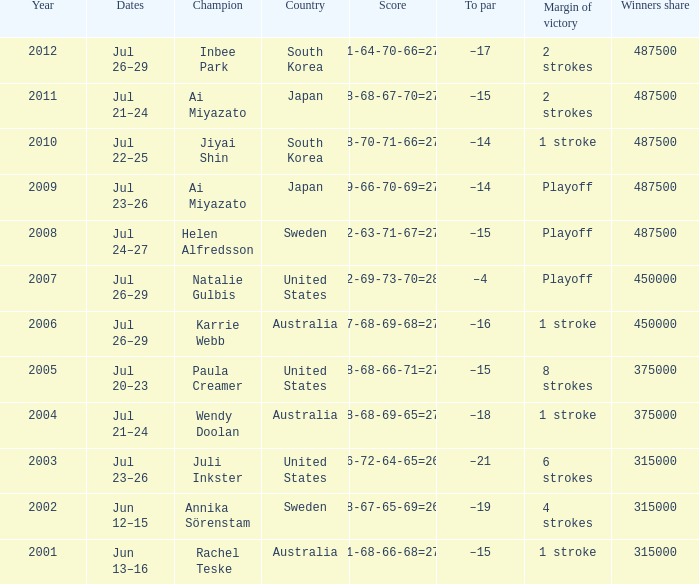What is the dollar amount of the purse when the success margin is 8 strokes? 1.0. 